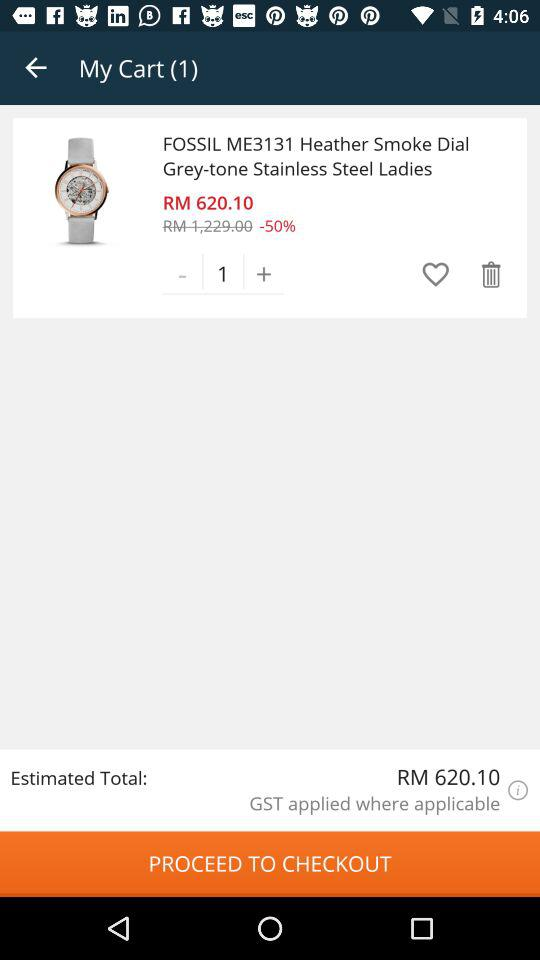How many items are in the cart?
Answer the question using a single word or phrase. 1 